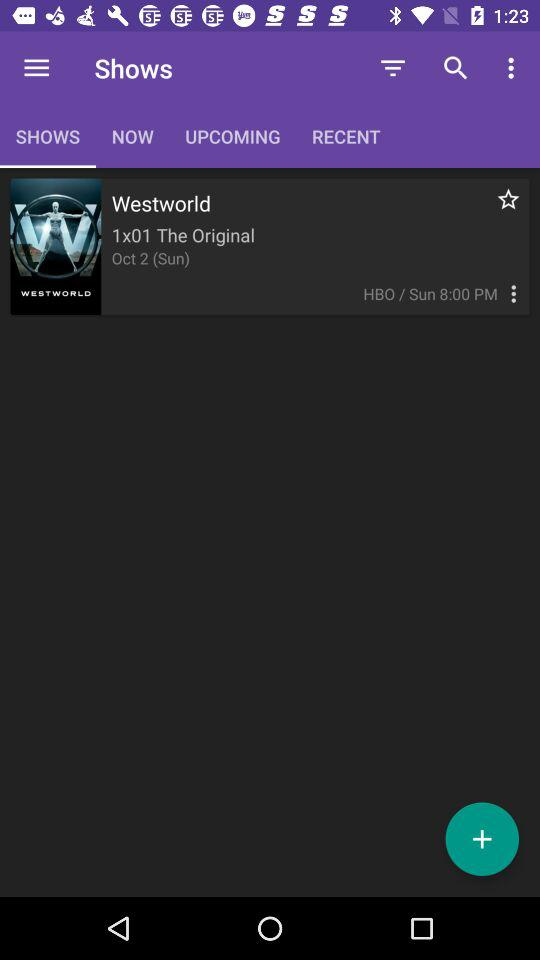Which tab is selected? The selected tab is "SHOWS". 